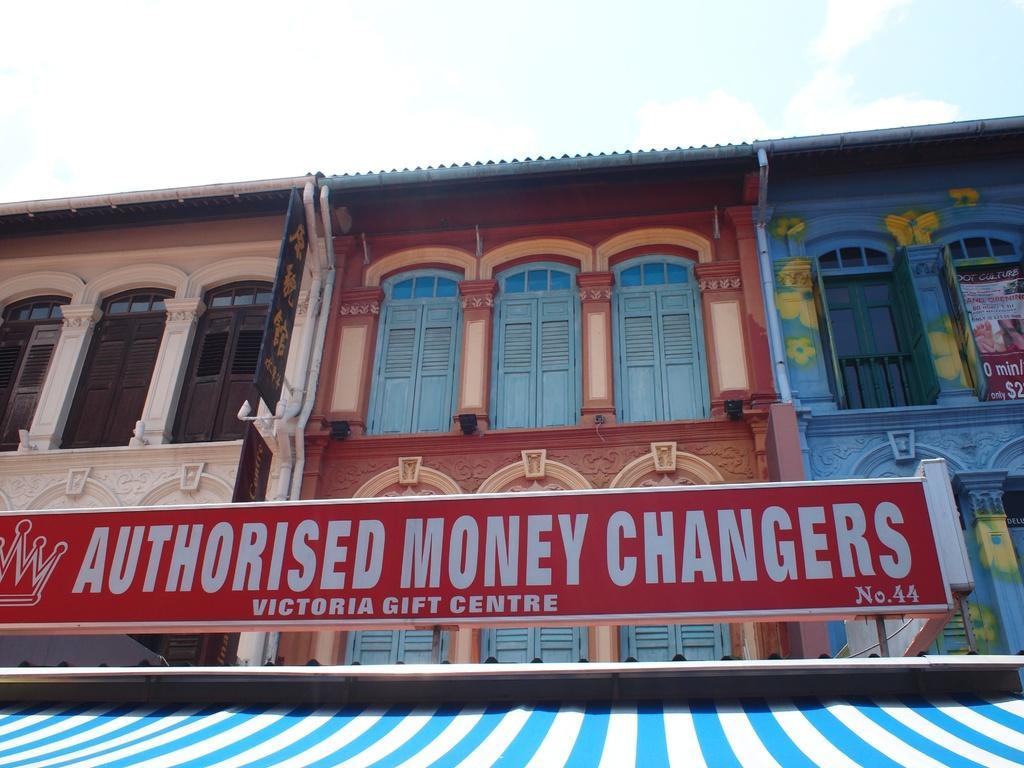Could you give a brief overview of what you see in this image? In this picture we can observe a red color board. There is a building which is in three colors. They are cream, maroon and blue. In the background there is a sky with clouds. 